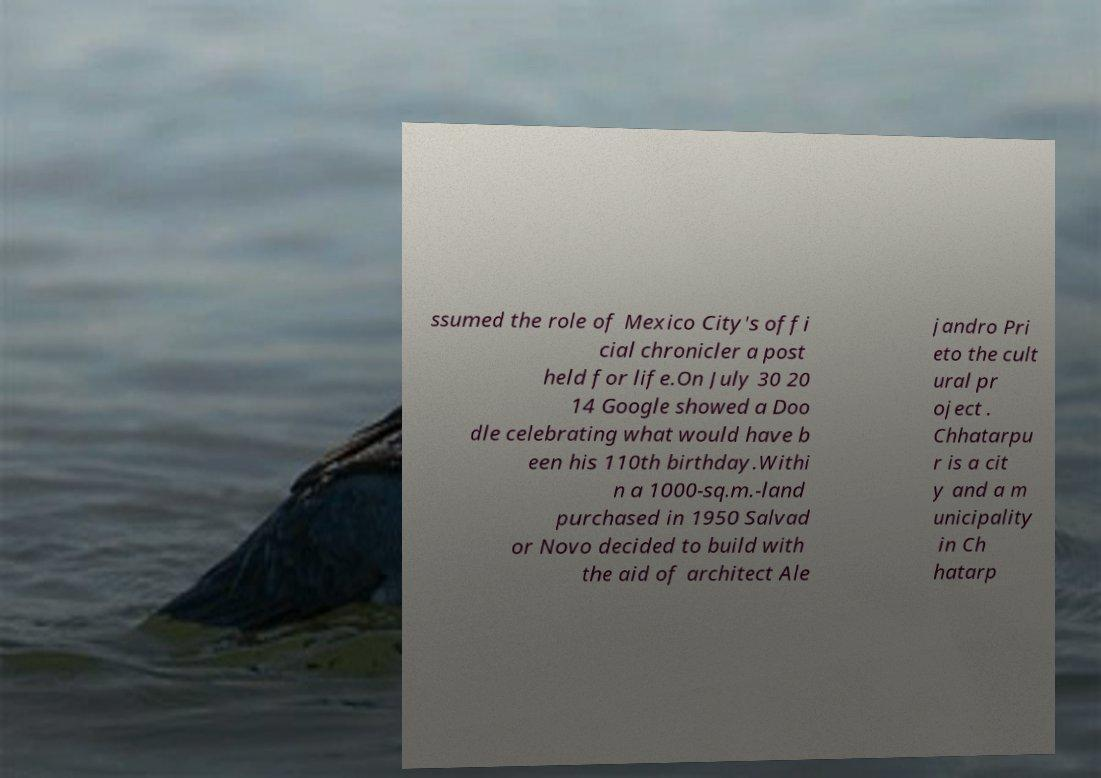Could you assist in decoding the text presented in this image and type it out clearly? ssumed the role of Mexico City's offi cial chronicler a post held for life.On July 30 20 14 Google showed a Doo dle celebrating what would have b een his 110th birthday.Withi n a 1000-sq.m.-land purchased in 1950 Salvad or Novo decided to build with the aid of architect Ale jandro Pri eto the cult ural pr oject . Chhatarpu r is a cit y and a m unicipality in Ch hatarp 